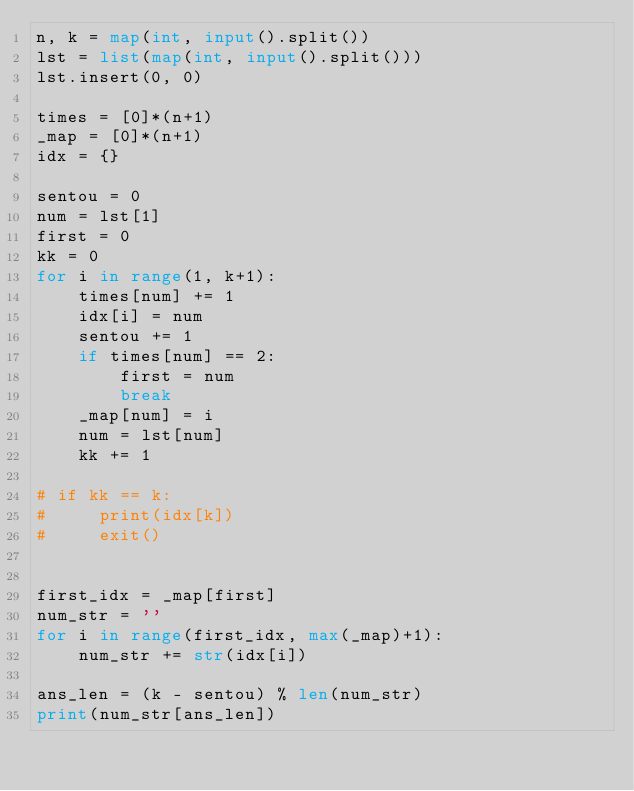Convert code to text. <code><loc_0><loc_0><loc_500><loc_500><_Python_>n, k = map(int, input().split())
lst = list(map(int, input().split()))
lst.insert(0, 0)

times = [0]*(n+1)
_map = [0]*(n+1)
idx = {}

sentou = 0
num = lst[1]
first = 0
kk = 0
for i in range(1, k+1):
    times[num] += 1
    idx[i] = num
    sentou += 1
    if times[num] == 2:
        first = num
        break
    _map[num] = i
    num = lst[num]
    kk += 1

# if kk == k:
#     print(idx[k])
#     exit()


first_idx = _map[first]
num_str = ''
for i in range(first_idx, max(_map)+1):
    num_str += str(idx[i])

ans_len = (k - sentou) % len(num_str)
print(num_str[ans_len])
</code> 